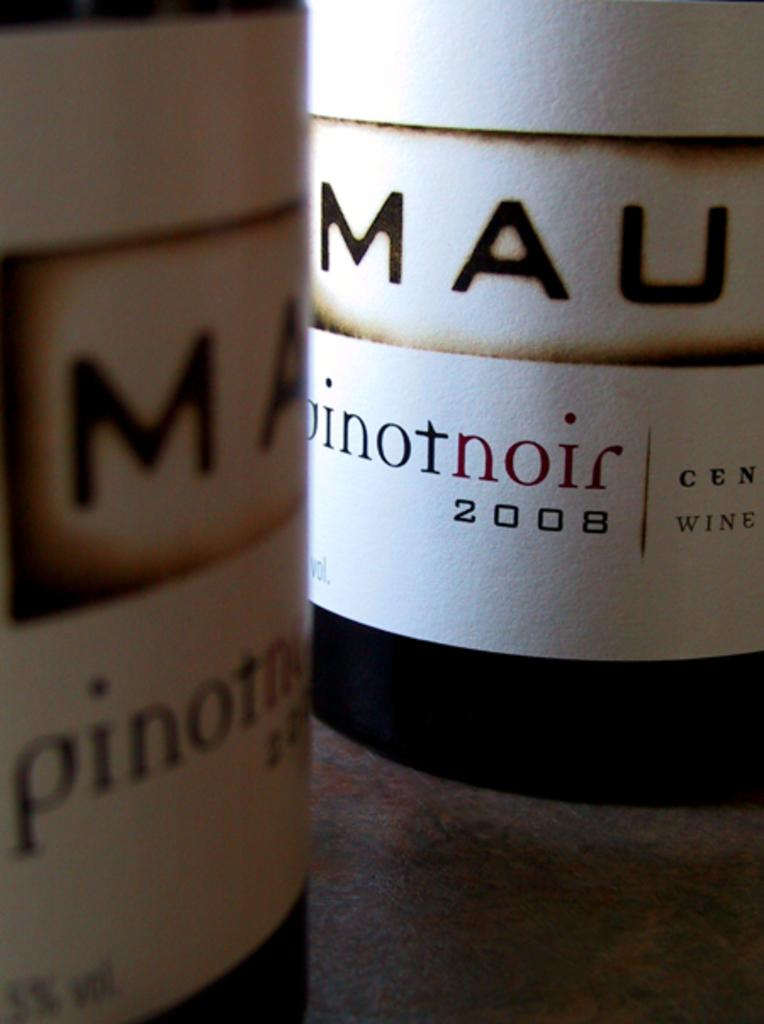Provide a one-sentence caption for the provided image. Two bottles of Pinot Nor from 2008, it is very up close and personal. 